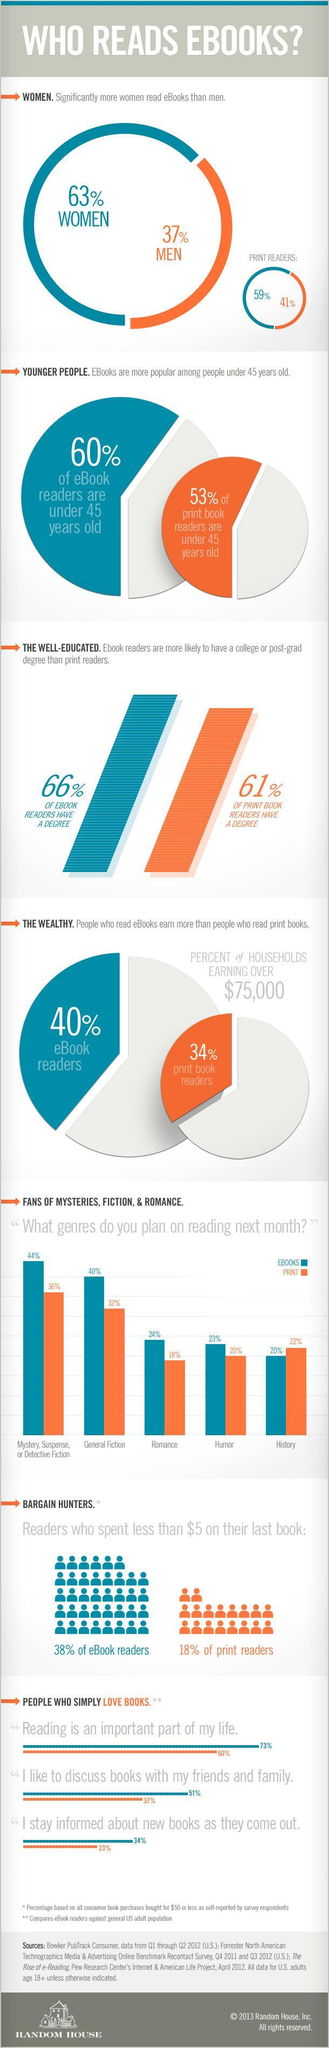How many of the fans of general fiction prefer ebooks?
Answer the question with a short phrase. 40% 20% of the fans of Humor books prefer which format of books? print What percent of men are print readers? 41% What percent of women read printed books? 59% How many of the digital book readers have a degree? 66% What percent of Mystery book lovers prefer printed books? 36% In which genre more people prefer printed books than e-books? History 